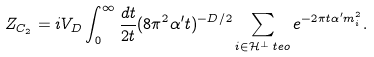Convert formula to latex. <formula><loc_0><loc_0><loc_500><loc_500>Z _ { C _ { 2 } } = i V _ { D } \int _ { 0 } ^ { \infty } \frac { d t } { 2 t } ( 8 \pi ^ { 2 } \alpha ^ { \prime } t ) ^ { - D / 2 } \sum _ { i \in \mathcal { H } ^ { \perp } _ { \ } t e { o } } e ^ { - 2 \pi t \alpha ^ { \prime } m ^ { 2 } _ { i } } .</formula> 